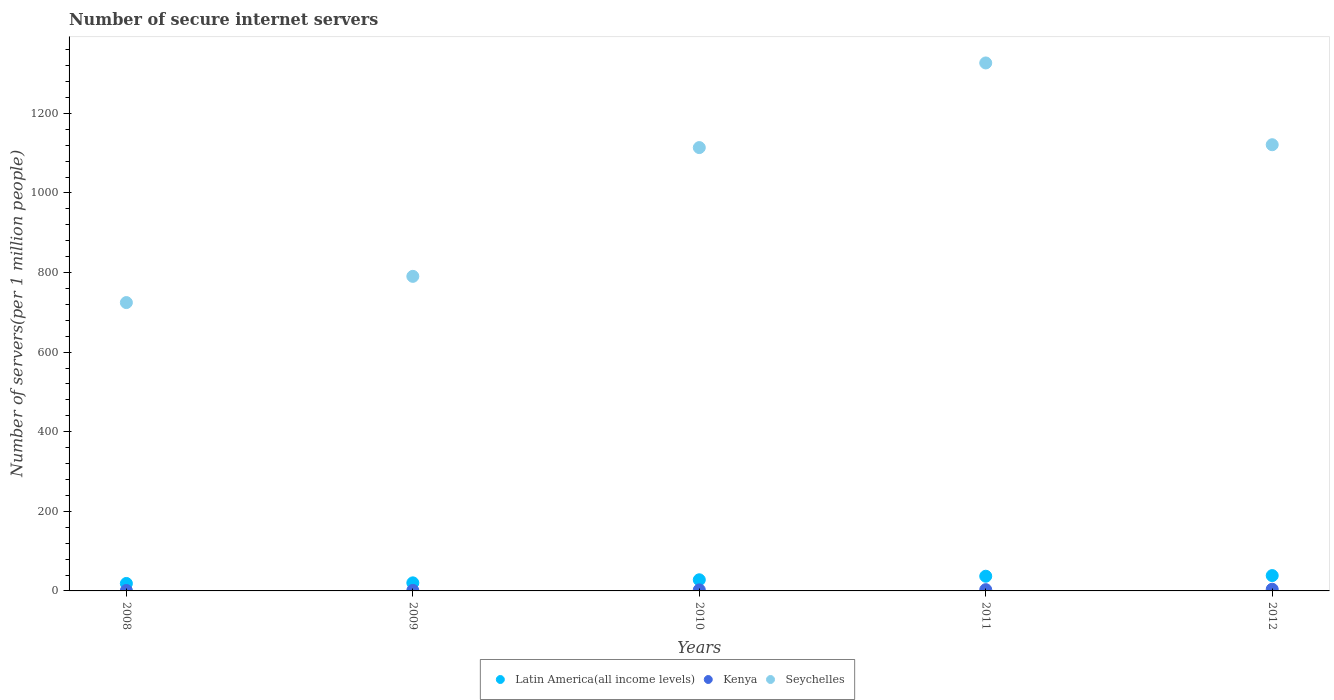How many different coloured dotlines are there?
Your answer should be very brief. 3. Is the number of dotlines equal to the number of legend labels?
Provide a succinct answer. Yes. What is the number of secure internet servers in Latin America(all income levels) in 2010?
Provide a short and direct response. 27.99. Across all years, what is the maximum number of secure internet servers in Seychelles?
Keep it short and to the point. 1326.61. Across all years, what is the minimum number of secure internet servers in Latin America(all income levels)?
Provide a succinct answer. 18.73. In which year was the number of secure internet servers in Seychelles maximum?
Provide a short and direct response. 2011. In which year was the number of secure internet servers in Seychelles minimum?
Make the answer very short. 2008. What is the total number of secure internet servers in Latin America(all income levels) in the graph?
Offer a very short reply. 142.45. What is the difference between the number of secure internet servers in Latin America(all income levels) in 2009 and that in 2012?
Provide a succinct answer. -18.24. What is the difference between the number of secure internet servers in Latin America(all income levels) in 2011 and the number of secure internet servers in Kenya in 2012?
Offer a terse response. 32.69. What is the average number of secure internet servers in Kenya per year?
Give a very brief answer. 2.48. In the year 2012, what is the difference between the number of secure internet servers in Kenya and number of secure internet servers in Seychelles?
Keep it short and to the point. -1116.91. What is the ratio of the number of secure internet servers in Kenya in 2009 to that in 2010?
Offer a very short reply. 0.51. What is the difference between the highest and the second highest number of secure internet servers in Seychelles?
Your response must be concise. 205.47. What is the difference between the highest and the lowest number of secure internet servers in Latin America(all income levels)?
Offer a very short reply. 19.79. Is the number of secure internet servers in Seychelles strictly greater than the number of secure internet servers in Latin America(all income levels) over the years?
Offer a very short reply. Yes. Is the number of secure internet servers in Latin America(all income levels) strictly less than the number of secure internet servers in Kenya over the years?
Offer a terse response. No. How many dotlines are there?
Ensure brevity in your answer.  3. How many years are there in the graph?
Your response must be concise. 5. What is the difference between two consecutive major ticks on the Y-axis?
Offer a terse response. 200. Are the values on the major ticks of Y-axis written in scientific E-notation?
Keep it short and to the point. No. How are the legend labels stacked?
Your answer should be very brief. Horizontal. What is the title of the graph?
Your answer should be very brief. Number of secure internet servers. Does "Serbia" appear as one of the legend labels in the graph?
Make the answer very short. No. What is the label or title of the X-axis?
Provide a short and direct response. Years. What is the label or title of the Y-axis?
Provide a short and direct response. Number of servers(per 1 million people). What is the Number of servers(per 1 million people) of Latin America(all income levels) in 2008?
Your answer should be very brief. 18.73. What is the Number of servers(per 1 million people) of Kenya in 2008?
Offer a terse response. 1.07. What is the Number of servers(per 1 million people) of Seychelles in 2008?
Keep it short and to the point. 724.5. What is the Number of servers(per 1 million people) of Latin America(all income levels) in 2009?
Provide a succinct answer. 20.28. What is the Number of servers(per 1 million people) in Kenya in 2009?
Keep it short and to the point. 1.32. What is the Number of servers(per 1 million people) in Seychelles in 2009?
Your response must be concise. 790.4. What is the Number of servers(per 1 million people) of Latin America(all income levels) in 2010?
Your answer should be very brief. 27.99. What is the Number of servers(per 1 million people) in Kenya in 2010?
Keep it short and to the point. 2.6. What is the Number of servers(per 1 million people) of Seychelles in 2010?
Offer a terse response. 1113.96. What is the Number of servers(per 1 million people) of Latin America(all income levels) in 2011?
Your answer should be compact. 36.93. What is the Number of servers(per 1 million people) in Kenya in 2011?
Your answer should be compact. 3.19. What is the Number of servers(per 1 million people) in Seychelles in 2011?
Provide a short and direct response. 1326.61. What is the Number of servers(per 1 million people) of Latin America(all income levels) in 2012?
Provide a succinct answer. 38.52. What is the Number of servers(per 1 million people) of Kenya in 2012?
Ensure brevity in your answer.  4.23. What is the Number of servers(per 1 million people) of Seychelles in 2012?
Provide a succinct answer. 1121.14. Across all years, what is the maximum Number of servers(per 1 million people) in Latin America(all income levels)?
Your answer should be very brief. 38.52. Across all years, what is the maximum Number of servers(per 1 million people) of Kenya?
Your answer should be very brief. 4.23. Across all years, what is the maximum Number of servers(per 1 million people) of Seychelles?
Keep it short and to the point. 1326.61. Across all years, what is the minimum Number of servers(per 1 million people) in Latin America(all income levels)?
Ensure brevity in your answer.  18.73. Across all years, what is the minimum Number of servers(per 1 million people) in Kenya?
Your answer should be very brief. 1.07. Across all years, what is the minimum Number of servers(per 1 million people) in Seychelles?
Offer a terse response. 724.5. What is the total Number of servers(per 1 million people) of Latin America(all income levels) in the graph?
Provide a short and direct response. 142.45. What is the total Number of servers(per 1 million people) in Kenya in the graph?
Provide a succinct answer. 12.42. What is the total Number of servers(per 1 million people) of Seychelles in the graph?
Offer a very short reply. 5076.61. What is the difference between the Number of servers(per 1 million people) of Latin America(all income levels) in 2008 and that in 2009?
Give a very brief answer. -1.55. What is the difference between the Number of servers(per 1 million people) of Kenya in 2008 and that in 2009?
Provide a succinct answer. -0.25. What is the difference between the Number of servers(per 1 million people) of Seychelles in 2008 and that in 2009?
Your answer should be compact. -65.89. What is the difference between the Number of servers(per 1 million people) of Latin America(all income levels) in 2008 and that in 2010?
Provide a short and direct response. -9.26. What is the difference between the Number of servers(per 1 million people) in Kenya in 2008 and that in 2010?
Your response must be concise. -1.53. What is the difference between the Number of servers(per 1 million people) in Seychelles in 2008 and that in 2010?
Keep it short and to the point. -389.45. What is the difference between the Number of servers(per 1 million people) of Latin America(all income levels) in 2008 and that in 2011?
Your response must be concise. -18.19. What is the difference between the Number of servers(per 1 million people) of Kenya in 2008 and that in 2011?
Your answer should be very brief. -2.11. What is the difference between the Number of servers(per 1 million people) in Seychelles in 2008 and that in 2011?
Provide a succinct answer. -602.1. What is the difference between the Number of servers(per 1 million people) of Latin America(all income levels) in 2008 and that in 2012?
Give a very brief answer. -19.79. What is the difference between the Number of servers(per 1 million people) in Kenya in 2008 and that in 2012?
Your response must be concise. -3.16. What is the difference between the Number of servers(per 1 million people) in Seychelles in 2008 and that in 2012?
Ensure brevity in your answer.  -396.64. What is the difference between the Number of servers(per 1 million people) of Latin America(all income levels) in 2009 and that in 2010?
Keep it short and to the point. -7.71. What is the difference between the Number of servers(per 1 million people) in Kenya in 2009 and that in 2010?
Ensure brevity in your answer.  -1.28. What is the difference between the Number of servers(per 1 million people) of Seychelles in 2009 and that in 2010?
Provide a short and direct response. -323.56. What is the difference between the Number of servers(per 1 million people) in Latin America(all income levels) in 2009 and that in 2011?
Provide a short and direct response. -16.64. What is the difference between the Number of servers(per 1 million people) of Kenya in 2009 and that in 2011?
Your answer should be very brief. -1.86. What is the difference between the Number of servers(per 1 million people) of Seychelles in 2009 and that in 2011?
Provide a succinct answer. -536.21. What is the difference between the Number of servers(per 1 million people) of Latin America(all income levels) in 2009 and that in 2012?
Your answer should be compact. -18.24. What is the difference between the Number of servers(per 1 million people) of Kenya in 2009 and that in 2012?
Offer a terse response. -2.91. What is the difference between the Number of servers(per 1 million people) in Seychelles in 2009 and that in 2012?
Offer a terse response. -330.74. What is the difference between the Number of servers(per 1 million people) in Latin America(all income levels) in 2010 and that in 2011?
Your answer should be compact. -8.93. What is the difference between the Number of servers(per 1 million people) of Kenya in 2010 and that in 2011?
Offer a very short reply. -0.58. What is the difference between the Number of servers(per 1 million people) in Seychelles in 2010 and that in 2011?
Provide a short and direct response. -212.65. What is the difference between the Number of servers(per 1 million people) in Latin America(all income levels) in 2010 and that in 2012?
Offer a terse response. -10.53. What is the difference between the Number of servers(per 1 million people) in Kenya in 2010 and that in 2012?
Keep it short and to the point. -1.63. What is the difference between the Number of servers(per 1 million people) in Seychelles in 2010 and that in 2012?
Your answer should be compact. -7.18. What is the difference between the Number of servers(per 1 million people) of Latin America(all income levels) in 2011 and that in 2012?
Ensure brevity in your answer.  -1.59. What is the difference between the Number of servers(per 1 million people) in Kenya in 2011 and that in 2012?
Provide a succinct answer. -1.04. What is the difference between the Number of servers(per 1 million people) of Seychelles in 2011 and that in 2012?
Ensure brevity in your answer.  205.47. What is the difference between the Number of servers(per 1 million people) in Latin America(all income levels) in 2008 and the Number of servers(per 1 million people) in Kenya in 2009?
Provide a short and direct response. 17.41. What is the difference between the Number of servers(per 1 million people) of Latin America(all income levels) in 2008 and the Number of servers(per 1 million people) of Seychelles in 2009?
Your response must be concise. -771.66. What is the difference between the Number of servers(per 1 million people) of Kenya in 2008 and the Number of servers(per 1 million people) of Seychelles in 2009?
Ensure brevity in your answer.  -789.32. What is the difference between the Number of servers(per 1 million people) in Latin America(all income levels) in 2008 and the Number of servers(per 1 million people) in Kenya in 2010?
Provide a succinct answer. 16.13. What is the difference between the Number of servers(per 1 million people) of Latin America(all income levels) in 2008 and the Number of servers(per 1 million people) of Seychelles in 2010?
Ensure brevity in your answer.  -1095.22. What is the difference between the Number of servers(per 1 million people) of Kenya in 2008 and the Number of servers(per 1 million people) of Seychelles in 2010?
Your response must be concise. -1112.89. What is the difference between the Number of servers(per 1 million people) in Latin America(all income levels) in 2008 and the Number of servers(per 1 million people) in Kenya in 2011?
Offer a very short reply. 15.55. What is the difference between the Number of servers(per 1 million people) in Latin America(all income levels) in 2008 and the Number of servers(per 1 million people) in Seychelles in 2011?
Your answer should be compact. -1307.88. What is the difference between the Number of servers(per 1 million people) in Kenya in 2008 and the Number of servers(per 1 million people) in Seychelles in 2011?
Make the answer very short. -1325.54. What is the difference between the Number of servers(per 1 million people) in Latin America(all income levels) in 2008 and the Number of servers(per 1 million people) in Kenya in 2012?
Ensure brevity in your answer.  14.5. What is the difference between the Number of servers(per 1 million people) of Latin America(all income levels) in 2008 and the Number of servers(per 1 million people) of Seychelles in 2012?
Keep it short and to the point. -1102.41. What is the difference between the Number of servers(per 1 million people) of Kenya in 2008 and the Number of servers(per 1 million people) of Seychelles in 2012?
Offer a terse response. -1120.07. What is the difference between the Number of servers(per 1 million people) in Latin America(all income levels) in 2009 and the Number of servers(per 1 million people) in Kenya in 2010?
Provide a succinct answer. 17.68. What is the difference between the Number of servers(per 1 million people) in Latin America(all income levels) in 2009 and the Number of servers(per 1 million people) in Seychelles in 2010?
Your response must be concise. -1093.68. What is the difference between the Number of servers(per 1 million people) in Kenya in 2009 and the Number of servers(per 1 million people) in Seychelles in 2010?
Make the answer very short. -1112.63. What is the difference between the Number of servers(per 1 million people) in Latin America(all income levels) in 2009 and the Number of servers(per 1 million people) in Kenya in 2011?
Make the answer very short. 17.09. What is the difference between the Number of servers(per 1 million people) of Latin America(all income levels) in 2009 and the Number of servers(per 1 million people) of Seychelles in 2011?
Your response must be concise. -1306.33. What is the difference between the Number of servers(per 1 million people) of Kenya in 2009 and the Number of servers(per 1 million people) of Seychelles in 2011?
Ensure brevity in your answer.  -1325.28. What is the difference between the Number of servers(per 1 million people) in Latin America(all income levels) in 2009 and the Number of servers(per 1 million people) in Kenya in 2012?
Provide a short and direct response. 16.05. What is the difference between the Number of servers(per 1 million people) in Latin America(all income levels) in 2009 and the Number of servers(per 1 million people) in Seychelles in 2012?
Your response must be concise. -1100.86. What is the difference between the Number of servers(per 1 million people) in Kenya in 2009 and the Number of servers(per 1 million people) in Seychelles in 2012?
Ensure brevity in your answer.  -1119.82. What is the difference between the Number of servers(per 1 million people) of Latin America(all income levels) in 2010 and the Number of servers(per 1 million people) of Kenya in 2011?
Your answer should be compact. 24.81. What is the difference between the Number of servers(per 1 million people) of Latin America(all income levels) in 2010 and the Number of servers(per 1 million people) of Seychelles in 2011?
Offer a terse response. -1298.61. What is the difference between the Number of servers(per 1 million people) in Kenya in 2010 and the Number of servers(per 1 million people) in Seychelles in 2011?
Offer a terse response. -1324.01. What is the difference between the Number of servers(per 1 million people) in Latin America(all income levels) in 2010 and the Number of servers(per 1 million people) in Kenya in 2012?
Give a very brief answer. 23.76. What is the difference between the Number of servers(per 1 million people) in Latin America(all income levels) in 2010 and the Number of servers(per 1 million people) in Seychelles in 2012?
Make the answer very short. -1093.15. What is the difference between the Number of servers(per 1 million people) of Kenya in 2010 and the Number of servers(per 1 million people) of Seychelles in 2012?
Provide a succinct answer. -1118.54. What is the difference between the Number of servers(per 1 million people) in Latin America(all income levels) in 2011 and the Number of servers(per 1 million people) in Kenya in 2012?
Provide a succinct answer. 32.69. What is the difference between the Number of servers(per 1 million people) of Latin America(all income levels) in 2011 and the Number of servers(per 1 million people) of Seychelles in 2012?
Make the answer very short. -1084.21. What is the difference between the Number of servers(per 1 million people) of Kenya in 2011 and the Number of servers(per 1 million people) of Seychelles in 2012?
Provide a succinct answer. -1117.95. What is the average Number of servers(per 1 million people) of Latin America(all income levels) per year?
Keep it short and to the point. 28.49. What is the average Number of servers(per 1 million people) of Kenya per year?
Ensure brevity in your answer.  2.48. What is the average Number of servers(per 1 million people) of Seychelles per year?
Ensure brevity in your answer.  1015.32. In the year 2008, what is the difference between the Number of servers(per 1 million people) of Latin America(all income levels) and Number of servers(per 1 million people) of Kenya?
Your answer should be compact. 17.66. In the year 2008, what is the difference between the Number of servers(per 1 million people) in Latin America(all income levels) and Number of servers(per 1 million people) in Seychelles?
Make the answer very short. -705.77. In the year 2008, what is the difference between the Number of servers(per 1 million people) of Kenya and Number of servers(per 1 million people) of Seychelles?
Ensure brevity in your answer.  -723.43. In the year 2009, what is the difference between the Number of servers(per 1 million people) in Latin America(all income levels) and Number of servers(per 1 million people) in Kenya?
Make the answer very short. 18.96. In the year 2009, what is the difference between the Number of servers(per 1 million people) of Latin America(all income levels) and Number of servers(per 1 million people) of Seychelles?
Offer a terse response. -770.11. In the year 2009, what is the difference between the Number of servers(per 1 million people) of Kenya and Number of servers(per 1 million people) of Seychelles?
Make the answer very short. -789.07. In the year 2010, what is the difference between the Number of servers(per 1 million people) in Latin America(all income levels) and Number of servers(per 1 million people) in Kenya?
Your answer should be very brief. 25.39. In the year 2010, what is the difference between the Number of servers(per 1 million people) in Latin America(all income levels) and Number of servers(per 1 million people) in Seychelles?
Provide a succinct answer. -1085.96. In the year 2010, what is the difference between the Number of servers(per 1 million people) of Kenya and Number of servers(per 1 million people) of Seychelles?
Your answer should be very brief. -1111.35. In the year 2011, what is the difference between the Number of servers(per 1 million people) in Latin America(all income levels) and Number of servers(per 1 million people) in Kenya?
Your answer should be compact. 33.74. In the year 2011, what is the difference between the Number of servers(per 1 million people) of Latin America(all income levels) and Number of servers(per 1 million people) of Seychelles?
Provide a short and direct response. -1289.68. In the year 2011, what is the difference between the Number of servers(per 1 million people) in Kenya and Number of servers(per 1 million people) in Seychelles?
Ensure brevity in your answer.  -1323.42. In the year 2012, what is the difference between the Number of servers(per 1 million people) in Latin America(all income levels) and Number of servers(per 1 million people) in Kenya?
Provide a short and direct response. 34.29. In the year 2012, what is the difference between the Number of servers(per 1 million people) of Latin America(all income levels) and Number of servers(per 1 million people) of Seychelles?
Keep it short and to the point. -1082.62. In the year 2012, what is the difference between the Number of servers(per 1 million people) in Kenya and Number of servers(per 1 million people) in Seychelles?
Your answer should be very brief. -1116.91. What is the ratio of the Number of servers(per 1 million people) of Latin America(all income levels) in 2008 to that in 2009?
Your response must be concise. 0.92. What is the ratio of the Number of servers(per 1 million people) in Kenya in 2008 to that in 2009?
Your answer should be very brief. 0.81. What is the ratio of the Number of servers(per 1 million people) of Seychelles in 2008 to that in 2009?
Offer a very short reply. 0.92. What is the ratio of the Number of servers(per 1 million people) of Latin America(all income levels) in 2008 to that in 2010?
Ensure brevity in your answer.  0.67. What is the ratio of the Number of servers(per 1 million people) in Kenya in 2008 to that in 2010?
Offer a terse response. 0.41. What is the ratio of the Number of servers(per 1 million people) of Seychelles in 2008 to that in 2010?
Provide a short and direct response. 0.65. What is the ratio of the Number of servers(per 1 million people) in Latin America(all income levels) in 2008 to that in 2011?
Your response must be concise. 0.51. What is the ratio of the Number of servers(per 1 million people) in Kenya in 2008 to that in 2011?
Ensure brevity in your answer.  0.34. What is the ratio of the Number of servers(per 1 million people) in Seychelles in 2008 to that in 2011?
Provide a short and direct response. 0.55. What is the ratio of the Number of servers(per 1 million people) of Latin America(all income levels) in 2008 to that in 2012?
Your response must be concise. 0.49. What is the ratio of the Number of servers(per 1 million people) in Kenya in 2008 to that in 2012?
Offer a terse response. 0.25. What is the ratio of the Number of servers(per 1 million people) in Seychelles in 2008 to that in 2012?
Offer a very short reply. 0.65. What is the ratio of the Number of servers(per 1 million people) of Latin America(all income levels) in 2009 to that in 2010?
Provide a succinct answer. 0.72. What is the ratio of the Number of servers(per 1 million people) of Kenya in 2009 to that in 2010?
Provide a succinct answer. 0.51. What is the ratio of the Number of servers(per 1 million people) of Seychelles in 2009 to that in 2010?
Offer a very short reply. 0.71. What is the ratio of the Number of servers(per 1 million people) of Latin America(all income levels) in 2009 to that in 2011?
Keep it short and to the point. 0.55. What is the ratio of the Number of servers(per 1 million people) of Kenya in 2009 to that in 2011?
Offer a very short reply. 0.42. What is the ratio of the Number of servers(per 1 million people) in Seychelles in 2009 to that in 2011?
Keep it short and to the point. 0.6. What is the ratio of the Number of servers(per 1 million people) of Latin America(all income levels) in 2009 to that in 2012?
Your response must be concise. 0.53. What is the ratio of the Number of servers(per 1 million people) in Kenya in 2009 to that in 2012?
Keep it short and to the point. 0.31. What is the ratio of the Number of servers(per 1 million people) in Seychelles in 2009 to that in 2012?
Provide a short and direct response. 0.7. What is the ratio of the Number of servers(per 1 million people) in Latin America(all income levels) in 2010 to that in 2011?
Provide a succinct answer. 0.76. What is the ratio of the Number of servers(per 1 million people) in Kenya in 2010 to that in 2011?
Your answer should be compact. 0.82. What is the ratio of the Number of servers(per 1 million people) in Seychelles in 2010 to that in 2011?
Your response must be concise. 0.84. What is the ratio of the Number of servers(per 1 million people) of Latin America(all income levels) in 2010 to that in 2012?
Keep it short and to the point. 0.73. What is the ratio of the Number of servers(per 1 million people) in Kenya in 2010 to that in 2012?
Offer a very short reply. 0.62. What is the ratio of the Number of servers(per 1 million people) in Seychelles in 2010 to that in 2012?
Provide a succinct answer. 0.99. What is the ratio of the Number of servers(per 1 million people) of Latin America(all income levels) in 2011 to that in 2012?
Offer a terse response. 0.96. What is the ratio of the Number of servers(per 1 million people) in Kenya in 2011 to that in 2012?
Your response must be concise. 0.75. What is the ratio of the Number of servers(per 1 million people) in Seychelles in 2011 to that in 2012?
Provide a short and direct response. 1.18. What is the difference between the highest and the second highest Number of servers(per 1 million people) of Latin America(all income levels)?
Your answer should be compact. 1.59. What is the difference between the highest and the second highest Number of servers(per 1 million people) in Kenya?
Offer a very short reply. 1.04. What is the difference between the highest and the second highest Number of servers(per 1 million people) in Seychelles?
Keep it short and to the point. 205.47. What is the difference between the highest and the lowest Number of servers(per 1 million people) in Latin America(all income levels)?
Keep it short and to the point. 19.79. What is the difference between the highest and the lowest Number of servers(per 1 million people) of Kenya?
Provide a succinct answer. 3.16. What is the difference between the highest and the lowest Number of servers(per 1 million people) in Seychelles?
Your response must be concise. 602.1. 